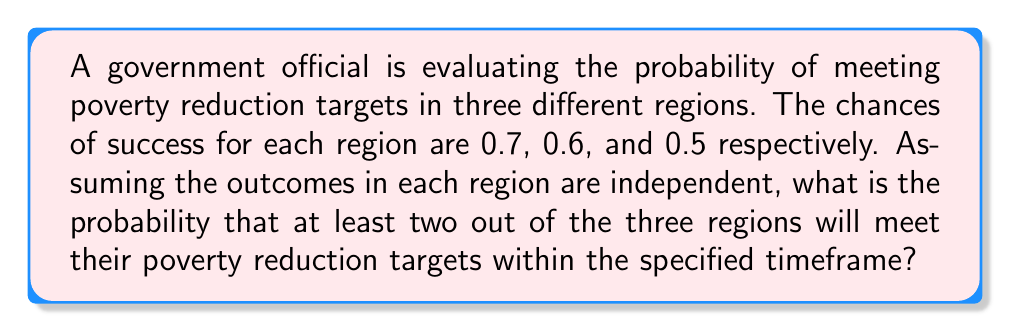Can you answer this question? Let's approach this step-by-step:

1) First, we need to identify the probability of success for each region:
   Region 1: $p_1 = 0.7$
   Region 2: $p_2 = 0.6$
   Region 3: $p_3 = 0.5$

2) We want the probability of at least two regions succeeding. This can happen in four ways:
   - All three regions succeed
   - Regions 1 and 2 succeed, 3 fails
   - Regions 1 and 3 succeed, 2 fails
   - Regions 2 and 3 succeed, 1 fails

3) Let's calculate each of these probabilities:

   a) All three succeed: 
      $P(\text{All}) = 0.7 \times 0.6 \times 0.5 = 0.21$

   b) 1 and 2 succeed, 3 fails:
      $P(1,2) = 0.7 \times 0.6 \times (1-0.5) = 0.21$

   c) 1 and 3 succeed, 2 fails:
      $P(1,3) = 0.7 \times (1-0.6) \times 0.5 = 0.14$

   d) 2 and 3 succeed, 1 fails:
      $P(2,3) = (1-0.7) \times 0.6 \times 0.5 = 0.09$

4) The total probability is the sum of these individual probabilities:

   $P(\text{at least two}) = P(\text{All}) + P(1,2) + P(1,3) + P(2,3)$

   $P(\text{at least two}) = 0.21 + 0.21 + 0.14 + 0.09 = 0.65$

Therefore, the probability of at least two out of the three regions meeting their poverty reduction targets is 0.65 or 65%.
Answer: 0.65 